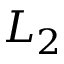Convert formula to latex. <formula><loc_0><loc_0><loc_500><loc_500>L _ { 2 }</formula> 